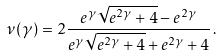<formula> <loc_0><loc_0><loc_500><loc_500>\nu ( \gamma ) = 2 \frac { e ^ { \gamma } \sqrt { e ^ { 2 \gamma } + 4 } - e ^ { 2 \gamma } } { e ^ { \gamma } \sqrt { e ^ { 2 \gamma } + 4 } + e ^ { 2 \gamma } + 4 } \, .</formula> 